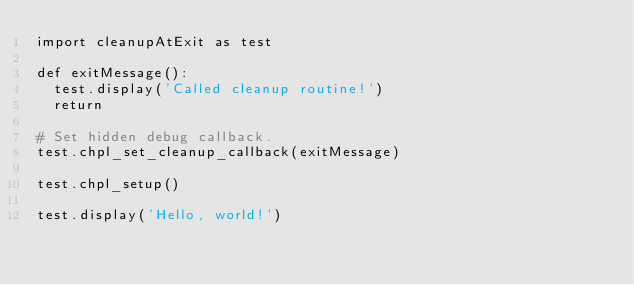Convert code to text. <code><loc_0><loc_0><loc_500><loc_500><_Python_>import cleanupAtExit as test

def exitMessage():
  test.display('Called cleanup routine!')
  return

# Set hidden debug callback.
test.chpl_set_cleanup_callback(exitMessage)

test.chpl_setup()

test.display('Hello, world!')
</code> 